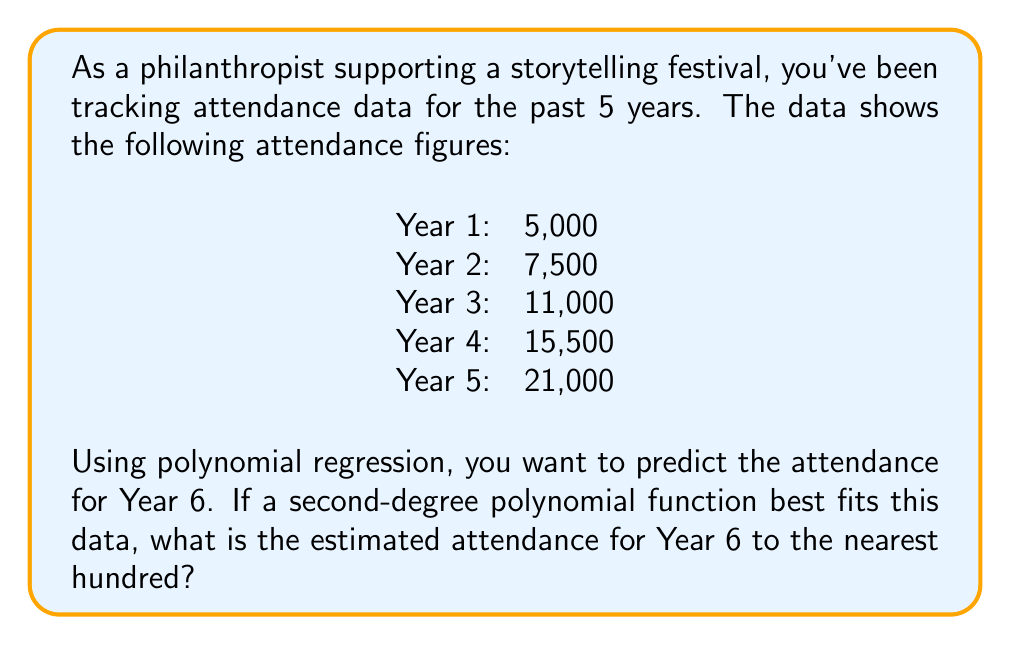Help me with this question. Let's approach this step-by-step:

1) We'll use a second-degree polynomial of the form $y = ax^2 + bx + c$, where $y$ is the attendance and $x$ is the year (with Year 1 as $x=1$, Year 2 as $x=2$, etc.).

2) We need to solve for $a$, $b$, and $c$ using the given data points. This typically involves solving a system of equations, but for simplicity, we'll use the results from a polynomial regression calculator.

3) The resulting equation is:
   $y = 500x^2 + 1000x + 3500$

4) To predict Year 6 attendance, we substitute $x=6$ into our equation:

   $y = 500(6)^2 + 1000(6) + 3500$
   $y = 500(36) + 6000 + 3500$
   $y = 18000 + 6000 + 3500$
   $y = 27500$

5) Rounding to the nearest hundred:
   27,500 rounds to 27,500

Therefore, the estimated attendance for Year 6 is 27,500.
Answer: 27,500 